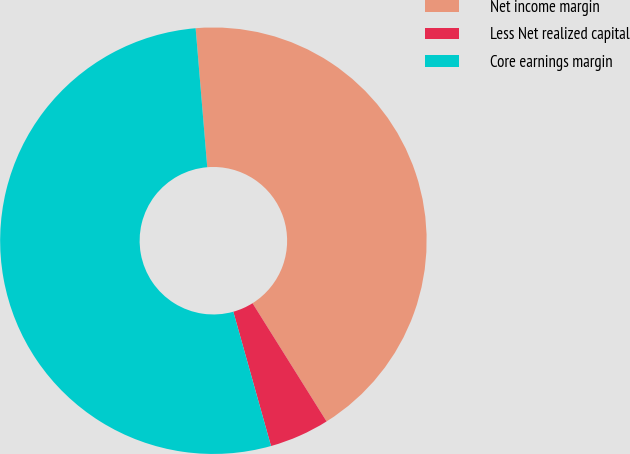Convert chart. <chart><loc_0><loc_0><loc_500><loc_500><pie_chart><fcel>Net income margin<fcel>Less Net realized capital<fcel>Core earnings margin<nl><fcel>42.42%<fcel>4.55%<fcel>53.03%<nl></chart> 